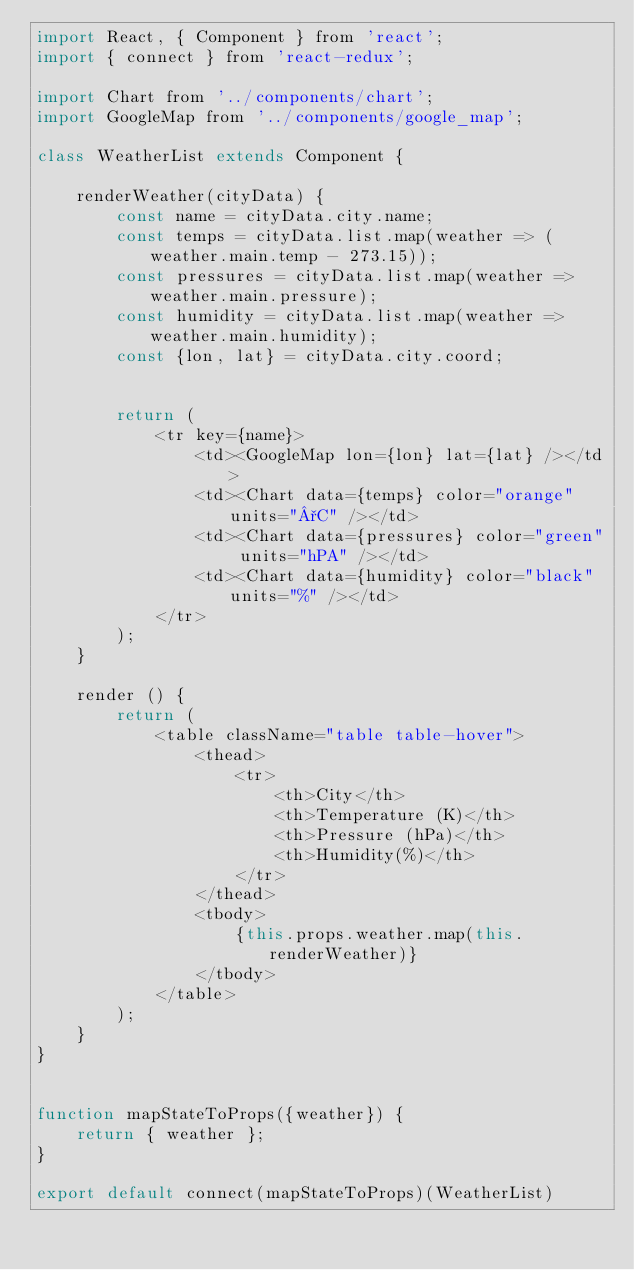<code> <loc_0><loc_0><loc_500><loc_500><_JavaScript_>import React, { Component } from 'react';
import { connect } from 'react-redux';

import Chart from '../components/chart';
import GoogleMap from '../components/google_map';

class WeatherList extends Component {

    renderWeather(cityData) {
        const name = cityData.city.name;
        const temps = cityData.list.map(weather => (weather.main.temp - 273.15));
        const pressures = cityData.list.map(weather => weather.main.pressure);
        const humidity = cityData.list.map(weather => weather.main.humidity);
        const {lon, lat} = cityData.city.coord;


        return (
            <tr key={name}>
                <td><GoogleMap lon={lon} lat={lat} /></td>
                <td><Chart data={temps} color="orange" units="°C" /></td>
                <td><Chart data={pressures} color="green" units="hPA" /></td>
                <td><Chart data={humidity} color="black" units="%" /></td>
            </tr>
        );
    }

    render () {
        return (
            <table className="table table-hover">
                <thead>
                    <tr>
                        <th>City</th>
                        <th>Temperature (K)</th>
                        <th>Pressure (hPa)</th>
                        <th>Humidity(%)</th>
                    </tr>
                </thead>
                <tbody>
                    {this.props.weather.map(this.renderWeather)}
                </tbody>
            </table>
        );
    }
}


function mapStateToProps({weather}) {
    return { weather };
}

export default connect(mapStateToProps)(WeatherList)</code> 